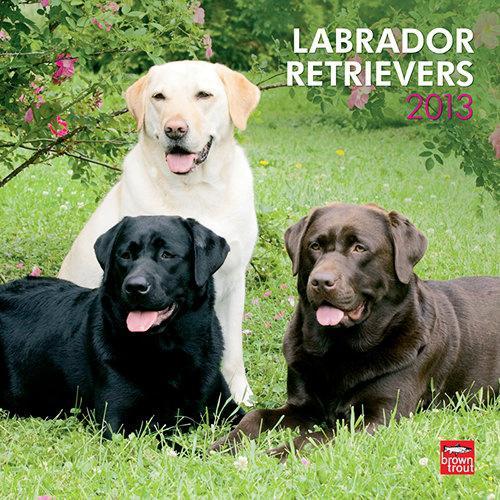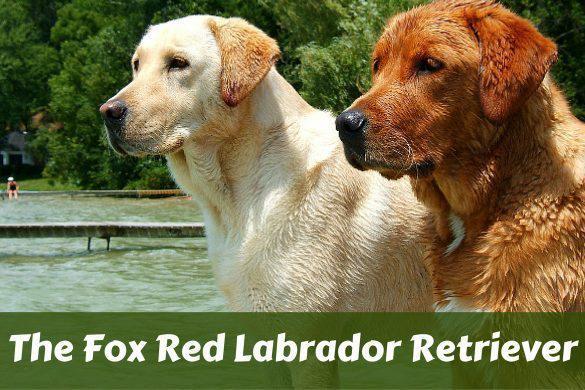The first image is the image on the left, the second image is the image on the right. For the images shown, is this caption "There are two dogs" true? Answer yes or no. No. The first image is the image on the left, the second image is the image on the right. Given the left and right images, does the statement "One image shows exactly two retrievers, which are side-by-side." hold true? Answer yes or no. Yes. 